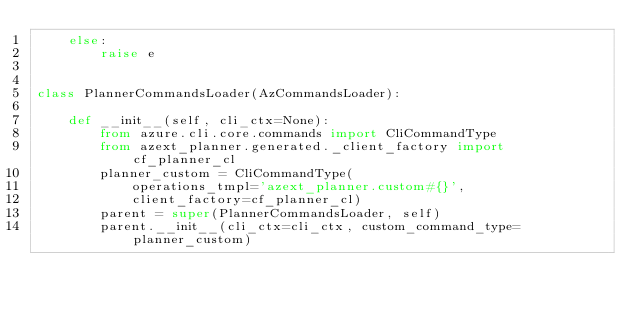<code> <loc_0><loc_0><loc_500><loc_500><_Python_>    else:
        raise e


class PlannerCommandsLoader(AzCommandsLoader):

    def __init__(self, cli_ctx=None):
        from azure.cli.core.commands import CliCommandType
        from azext_planner.generated._client_factory import cf_planner_cl
        planner_custom = CliCommandType(
            operations_tmpl='azext_planner.custom#{}',
            client_factory=cf_planner_cl)
        parent = super(PlannerCommandsLoader, self)
        parent.__init__(cli_ctx=cli_ctx, custom_command_type=planner_custom)
</code> 